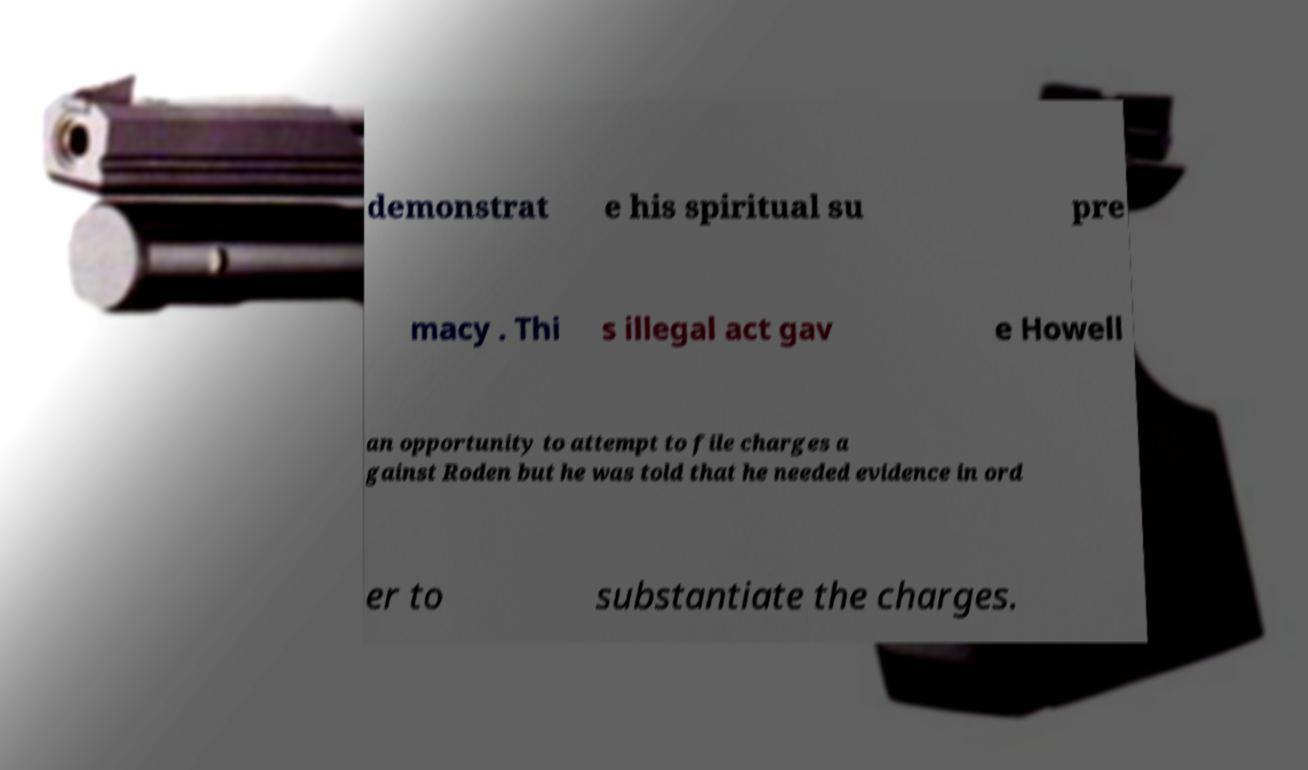What messages or text are displayed in this image? I need them in a readable, typed format. demonstrat e his spiritual su pre macy . Thi s illegal act gav e Howell an opportunity to attempt to file charges a gainst Roden but he was told that he needed evidence in ord er to substantiate the charges. 